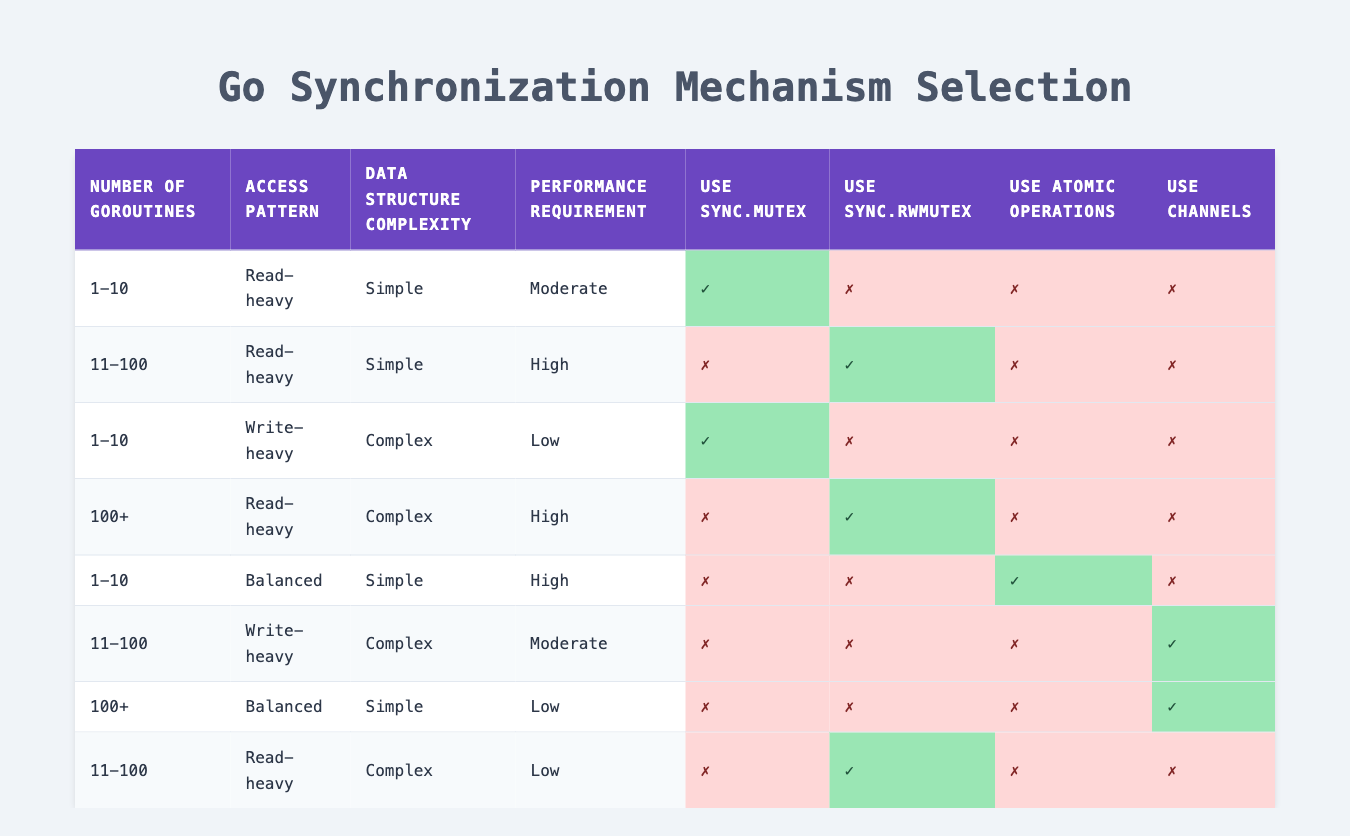What is the synchronization mechanism recommended for 1-10 goroutines with a read-heavy pattern and moderate performance requirement? The table indicates that for the conditions of 1-10 goroutines, read-heavy access pattern, and moderate performance requirement, the recommended mechanism is sync.Mutex, marked with a check (✓) in the corresponding row.
Answer: Use sync.Mutex Is sync.RWMutex recommended for 11-100 goroutines when access is read-heavy and the data structure is simple with high performance requirement? According to the table, for this scenario, sync.RWMutex is marked with a check (✓), which indicates it is recommended.
Answer: Yes For a situation with 1-10 goroutines and a balanced access pattern, what is the recommended synchronization mechanism? In the specified conditions, the table shows that user sync.Mutex, sync.RWMutex, and use of atomic operations are all marked with a cross (✗), indicating none of these are recommended. However, using channels is not recommended.
Answer: None How many synchronization mechanisms are recommended for the case of 100+ goroutines, a read-heavy pattern, complex data structure, and low performance requirement? Reviewing the conditions in the table, we see none of the synchronization mechanisms (sync.Mutex, sync.RWMutex, atomic operations, and channels) are recommended, as they all displayed a cross (✗). Thus, the total count of recommended mechanisms is zero.
Answer: 0 What is the synchronization recommendation if you have 11-100 goroutines, a write-heavy pattern, complex data structure, and moderate performance requirements? The table indicates that in this case, the only recommended synchronization mechanism is to use channels, which is marked with a check (✓) while all other mechanisms are marked with a cross (✗).
Answer: Use channels Is there a synchronization mechanism recommended for cases with 1-10 goroutines, read-heavy access, and complex data structure with low performance requirement? Looking at the table, sync.Mutex is the only mechanism marked with a check (✓), while the other recommended mechanisms (sync.RWMutex, atomic operations, and channels) are marked with crosses (✗). Therefore, sync.Mutex is recommended.
Answer: Yes What synchronization mechanisms are available when you have 100+ goroutines, a balanced access pattern, a simple data structure, and a low performance requirement? The table shows that for this case, there is only one recommended mechanism, which is using channels, indicated by a check (✓) in the corresponding row.
Answer: Use channels How many conditions exist in the table where sync.RWMutex is used? By reviewing the entries, sync.RWMutex appears as a recommended option in the rows corresponding to two different sets of conditions: for 11-100 goroutines read-heavy with simple data structure (high performance) and for 11-100 goroutines read-heavy with complex structure. Thus, it is present in two unique rules.
Answer: 2 